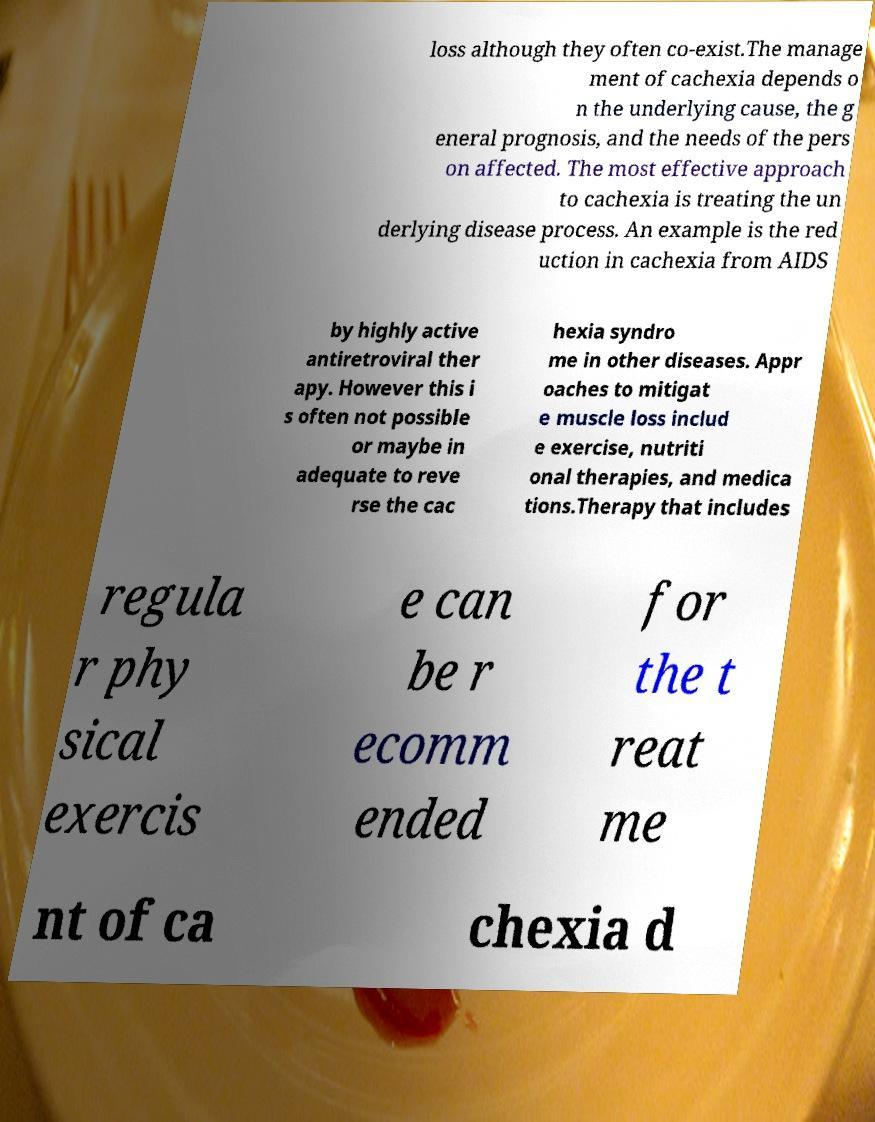Please identify and transcribe the text found in this image. loss although they often co-exist.The manage ment of cachexia depends o n the underlying cause, the g eneral prognosis, and the needs of the pers on affected. The most effective approach to cachexia is treating the un derlying disease process. An example is the red uction in cachexia from AIDS by highly active antiretroviral ther apy. However this i s often not possible or maybe in adequate to reve rse the cac hexia syndro me in other diseases. Appr oaches to mitigat e muscle loss includ e exercise, nutriti onal therapies, and medica tions.Therapy that includes regula r phy sical exercis e can be r ecomm ended for the t reat me nt of ca chexia d 